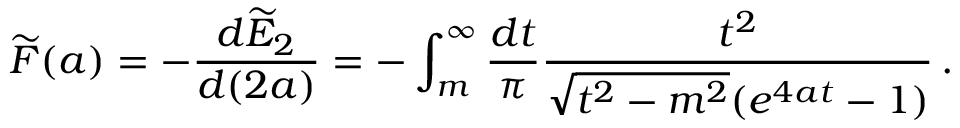<formula> <loc_0><loc_0><loc_500><loc_500>\widetilde { F } ( a ) = - \frac { d \widetilde { E } _ { 2 } } { d ( 2 a ) } = - \int _ { m } ^ { \infty } \frac { d t } { \pi } \frac { t ^ { 2 } } { \sqrt { t ^ { 2 } - m ^ { 2 } } ( e ^ { 4 a t } - 1 ) } \, .</formula> 